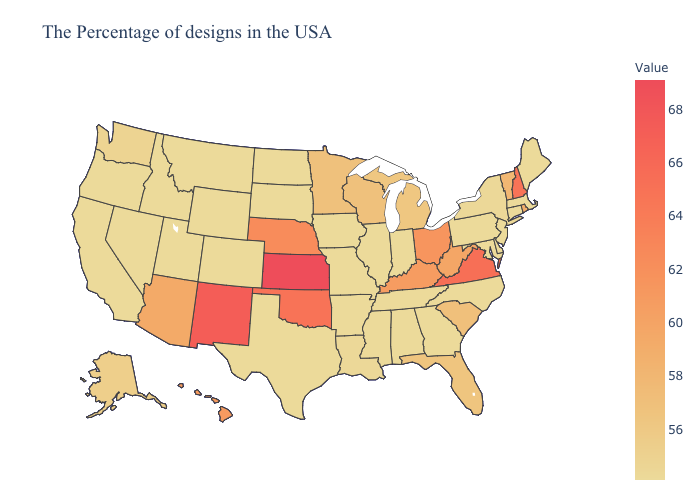Among the states that border North Carolina , does Virginia have the highest value?
Write a very short answer. Yes. Among the states that border West Virginia , which have the lowest value?
Give a very brief answer. Maryland, Pennsylvania. Does Oklahoma have a lower value than Michigan?
Write a very short answer. No. Which states have the lowest value in the MidWest?
Concise answer only. Indiana, Illinois, Missouri, Iowa, South Dakota, North Dakota. 